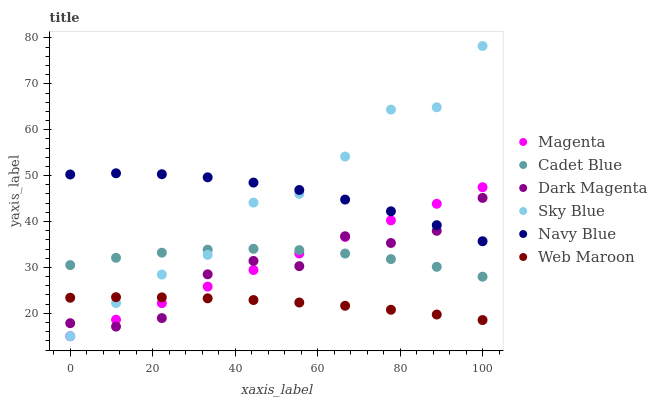Does Web Maroon have the minimum area under the curve?
Answer yes or no. Yes. Does Navy Blue have the maximum area under the curve?
Answer yes or no. Yes. Does Dark Magenta have the minimum area under the curve?
Answer yes or no. No. Does Dark Magenta have the maximum area under the curve?
Answer yes or no. No. Is Magenta the smoothest?
Answer yes or no. Yes. Is Sky Blue the roughest?
Answer yes or no. Yes. Is Dark Magenta the smoothest?
Answer yes or no. No. Is Dark Magenta the roughest?
Answer yes or no. No. Does Sky Blue have the lowest value?
Answer yes or no. Yes. Does Dark Magenta have the lowest value?
Answer yes or no. No. Does Sky Blue have the highest value?
Answer yes or no. Yes. Does Dark Magenta have the highest value?
Answer yes or no. No. Is Cadet Blue less than Navy Blue?
Answer yes or no. Yes. Is Navy Blue greater than Web Maroon?
Answer yes or no. Yes. Does Navy Blue intersect Dark Magenta?
Answer yes or no. Yes. Is Navy Blue less than Dark Magenta?
Answer yes or no. No. Is Navy Blue greater than Dark Magenta?
Answer yes or no. No. Does Cadet Blue intersect Navy Blue?
Answer yes or no. No. 